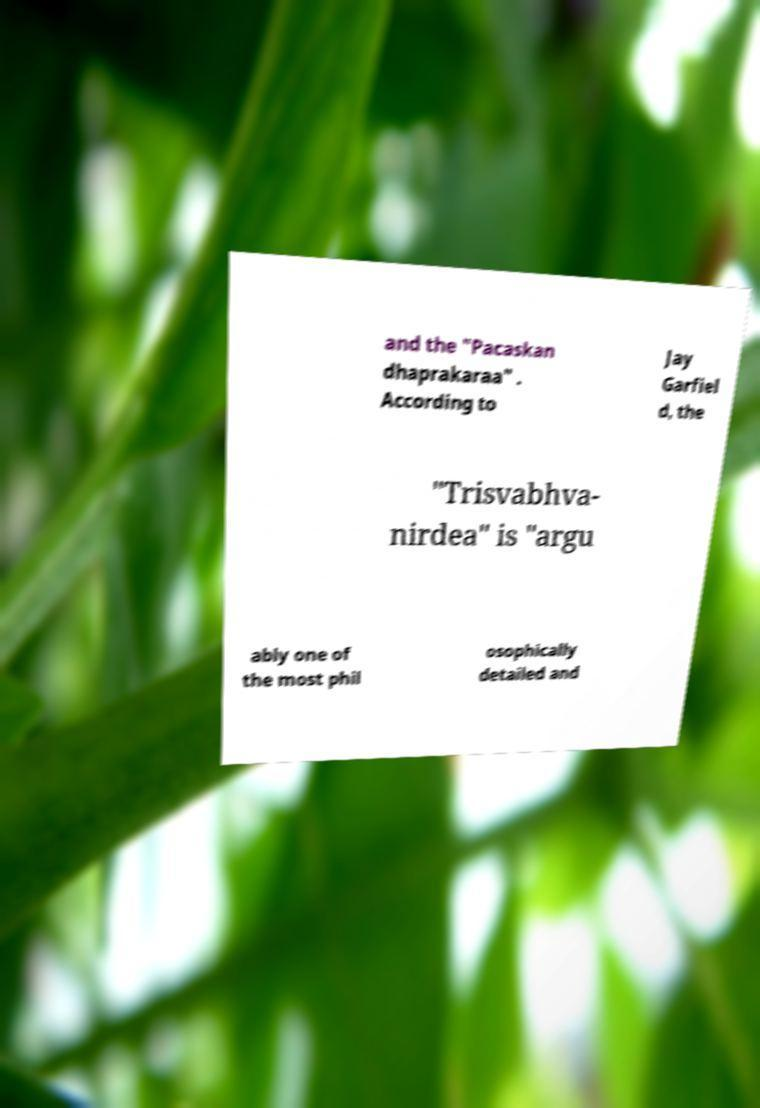Can you read and provide the text displayed in the image?This photo seems to have some interesting text. Can you extract and type it out for me? and the "Pacaskan dhaprakaraa" . According to Jay Garfiel d, the "Trisvabhva- nirdea" is "argu ably one of the most phil osophically detailed and 